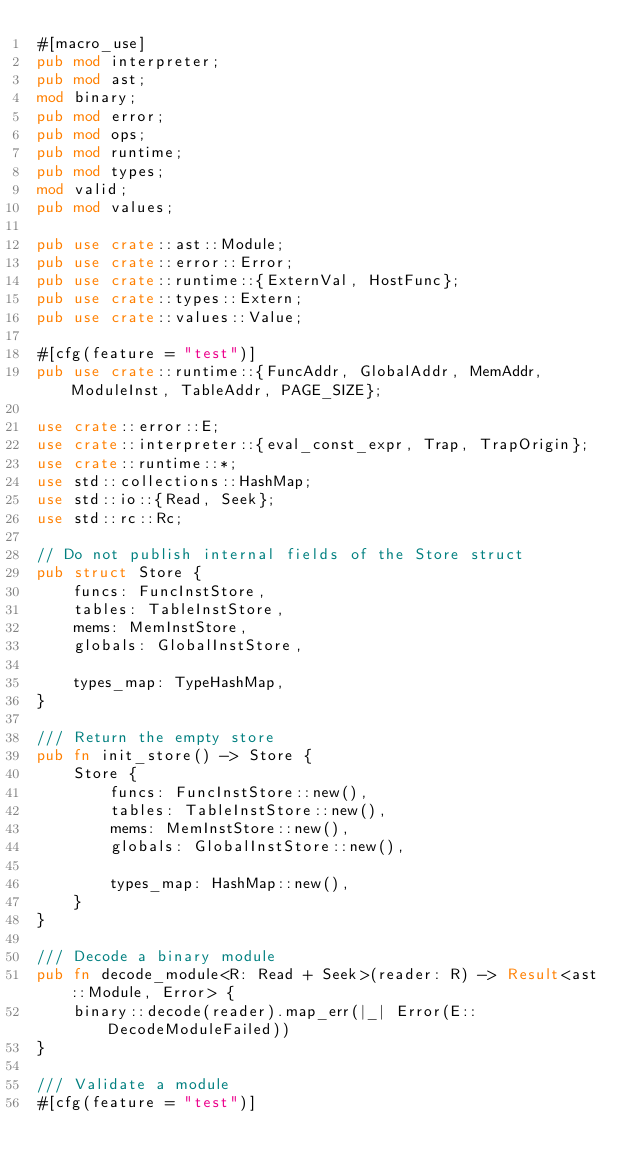<code> <loc_0><loc_0><loc_500><loc_500><_Rust_>#[macro_use]
pub mod interpreter;
pub mod ast;
mod binary;
pub mod error;
pub mod ops;
pub mod runtime;
pub mod types;
mod valid;
pub mod values;

pub use crate::ast::Module;
pub use crate::error::Error;
pub use crate::runtime::{ExternVal, HostFunc};
pub use crate::types::Extern;
pub use crate::values::Value;

#[cfg(feature = "test")]
pub use crate::runtime::{FuncAddr, GlobalAddr, MemAddr, ModuleInst, TableAddr, PAGE_SIZE};

use crate::error::E;
use crate::interpreter::{eval_const_expr, Trap, TrapOrigin};
use crate::runtime::*;
use std::collections::HashMap;
use std::io::{Read, Seek};
use std::rc::Rc;

// Do not publish internal fields of the Store struct
pub struct Store {
    funcs: FuncInstStore,
    tables: TableInstStore,
    mems: MemInstStore,
    globals: GlobalInstStore,

    types_map: TypeHashMap,
}

/// Return the empty store
pub fn init_store() -> Store {
    Store {
        funcs: FuncInstStore::new(),
        tables: TableInstStore::new(),
        mems: MemInstStore::new(),
        globals: GlobalInstStore::new(),

        types_map: HashMap::new(),
    }
}

/// Decode a binary module
pub fn decode_module<R: Read + Seek>(reader: R) -> Result<ast::Module, Error> {
    binary::decode(reader).map_err(|_| Error(E::DecodeModuleFailed))
}

/// Validate a module
#[cfg(feature = "test")]</code> 